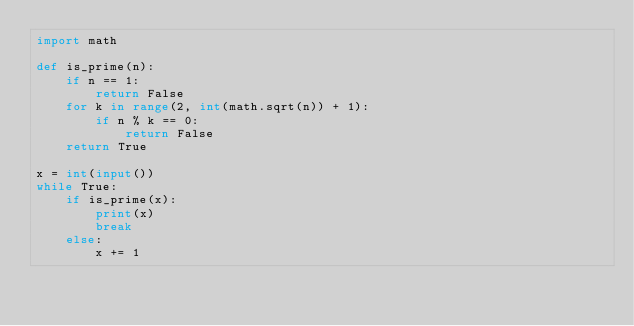Convert code to text. <code><loc_0><loc_0><loc_500><loc_500><_Python_>import math

def is_prime(n):
    if n == 1: 
        return False
    for k in range(2, int(math.sqrt(n)) + 1):
        if n % k == 0:
            return False
    return True

x = int(input())
while True:
    if is_prime(x):
        print(x)
        break
    else:
        x += 1</code> 